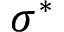Convert formula to latex. <formula><loc_0><loc_0><loc_500><loc_500>\sigma ^ { * }</formula> 